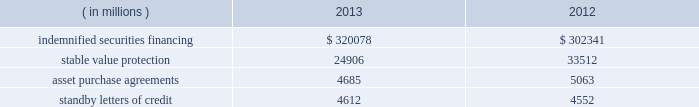State street corporation notes to consolidated financial statements ( continued ) with respect to the 5.25% ( 5.25 % ) subordinated bank notes due 2018 , state street bank is required to make semi- annual interest payments on the outstanding principal balance of the notes on april 15 and october 15 of each year , and the notes qualify for inclusion in tier 2 regulatory capital under current federal regulatory capital guidelines .
With respect to the 5.30% ( 5.30 % ) subordinated notes due 2016 and the floating-rate subordinated notes due 2015 , state street bank is required to make semi-annual interest payments on the outstanding principal balance of the 5.30% ( 5.30 % ) subordinated notes on january 15 and july 15 of each year , and quarterly interest payments on the outstanding principal balance of the floating-rate notes on march 8 , june 8 , september 8 and december 8 of each year .
Each of the subordinated notes qualifies for inclusion in tier 2 regulatory capital under current federal regulatory capital guidelines .
Note 11 .
Commitments , guarantees and contingencies commitments : we had unfunded off-balance sheet commitments to extend credit totaling $ 21.30 billion and $ 17.86 billion as of december 31 , 2013 and 2012 , respectively .
The potential losses associated with these commitments equal the gross contractual amounts , and do not consider the value of any collateral .
Approximately 75% ( 75 % ) of our unfunded commitments to extend credit expire within one year from the date of issue .
Since many of these commitments are expected to expire or renew without being drawn upon , the gross contractual amounts do not necessarily represent our future cash requirements .
Guarantees : off-balance sheet guarantees are composed of indemnified securities financing , stable value protection , unfunded commitments to purchase assets , and standby letters of credit .
The potential losses associated with these guarantees equal the gross contractual amounts , and do not consider the value of any collateral .
The table presents the aggregate gross contractual amounts of our off-balance sheet guarantees as of december 31 , 2013 and 2012 .
Amounts presented do not reflect participations to independent third parties. .
Indemnified securities financing on behalf of our clients , we lend their securities , as agent , to brokers and other institutions .
In most circumstances , we indemnify our clients for the fair market value of those securities against a failure of the borrower to return such securities .
We require the borrowers to maintain collateral in an amount equal to or in excess of 100% ( 100 % ) of the fair market value of the securities borrowed .
Securities on loan and the collateral are revalued daily to determine if additional collateral is necessary or if excess collateral is required to be returned to the borrower .
Collateral received in connection with our securities lending services is held by us as agent and is not recorded in our consolidated statement of condition .
The cash collateral held by us as agent is invested on behalf of our clients .
In certain cases , the cash collateral is invested in third-party repurchase agreements , for which we indemnify the client against loss of the principal invested .
We require the counterparty to the indemnified repurchase agreement to provide collateral in an amount equal to or in excess of 100% ( 100 % ) of the amount of the repurchase agreement .
In our role as agent , the indemnified repurchase agreements and the related collateral held by us are not recorded in our consolidated statement of condition. .
What is the percentage change in the balance of asset purchase agreements from 2012 to 2013? 
Computations: ((4685 - 5063) / 5063)
Answer: -0.07466. 